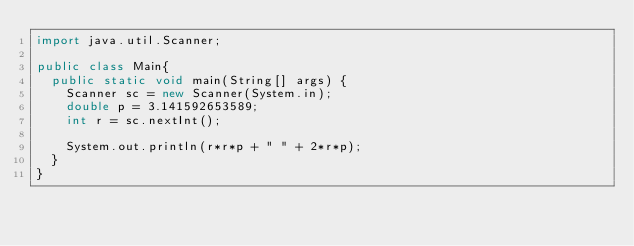<code> <loc_0><loc_0><loc_500><loc_500><_Java_>import java.util.Scanner;

public class Main{
	public static void main(String[] args) {
		Scanner sc = new Scanner(System.in);
		double p = 3.141592653589;
		int r = sc.nextInt();

		System.out.println(r*r*p + " " + 2*r*p);
	}
}</code> 